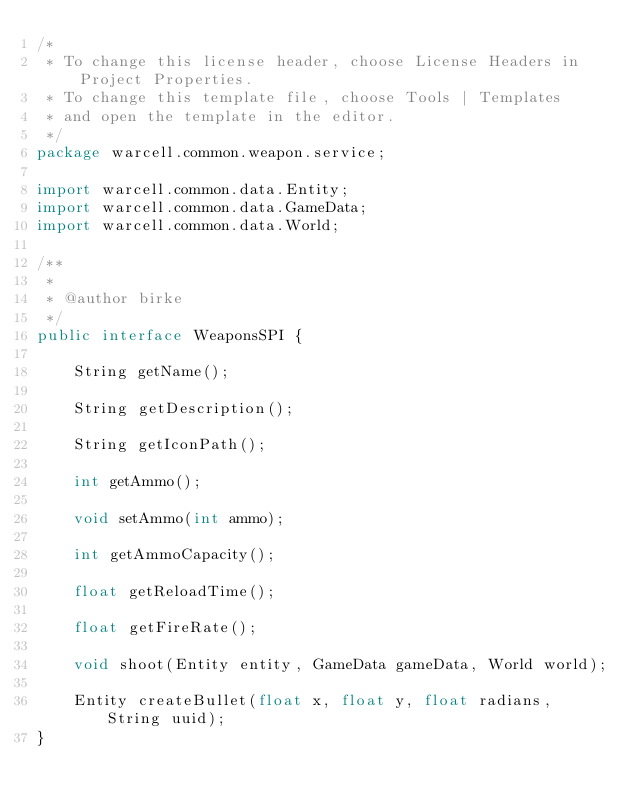Convert code to text. <code><loc_0><loc_0><loc_500><loc_500><_Java_>/*
 * To change this license header, choose License Headers in Project Properties.
 * To change this template file, choose Tools | Templates
 * and open the template in the editor.
 */
package warcell.common.weapon.service;

import warcell.common.data.Entity;
import warcell.common.data.GameData;
import warcell.common.data.World;

/**
 *
 * @author birke
 */
public interface WeaponsSPI {

    String getName();

    String getDescription();

    String getIconPath();

    int getAmmo();

    void setAmmo(int ammo);

    int getAmmoCapacity();

    float getReloadTime();

    float getFireRate();

    void shoot(Entity entity, GameData gameData, World world);

    Entity createBullet(float x, float y, float radians, String uuid);
}
</code> 